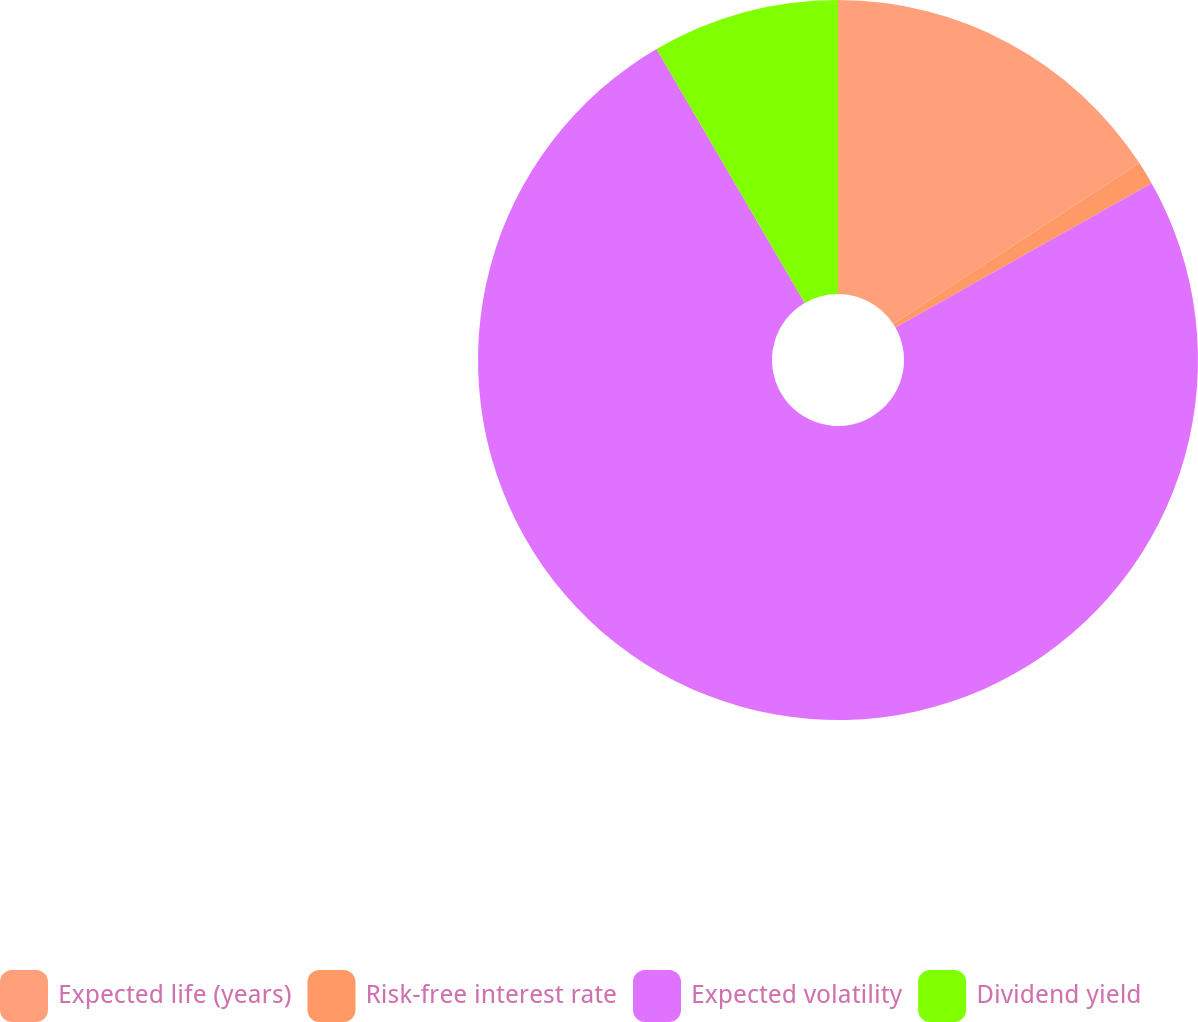Convert chart to OTSL. <chart><loc_0><loc_0><loc_500><loc_500><pie_chart><fcel>Expected life (years)<fcel>Risk-free interest rate<fcel>Expected volatility<fcel>Dividend yield<nl><fcel>15.79%<fcel>1.04%<fcel>74.76%<fcel>8.41%<nl></chart> 